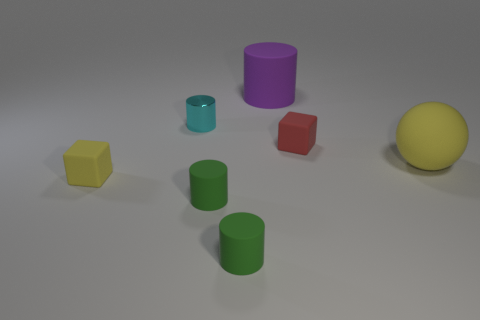Is the size of the yellow thing on the left side of the rubber sphere the same as the cyan metal cylinder that is on the left side of the red object?
Your answer should be compact. Yes. There is a cyan metal object that is behind the small rubber cube that is in front of the rubber cube behind the tiny yellow rubber block; what shape is it?
Give a very brief answer. Cylinder. Is there anything else that is the same material as the cyan cylinder?
Your answer should be very brief. No. There is a purple rubber object that is the same shape as the small shiny object; what is its size?
Provide a succinct answer. Large. The object that is in front of the red matte cube and on the right side of the big cylinder is what color?
Provide a succinct answer. Yellow. Are the yellow block and the tiny block that is behind the big matte ball made of the same material?
Offer a terse response. Yes. Are there fewer big matte objects that are to the left of the yellow ball than rubber cylinders?
Keep it short and to the point. Yes. What number of other objects are the same shape as the large purple thing?
Offer a terse response. 3. Is there anything else of the same color as the large matte cylinder?
Your response must be concise. No. Does the ball have the same color as the small rubber thing that is on the left side of the small shiny object?
Offer a terse response. Yes. 